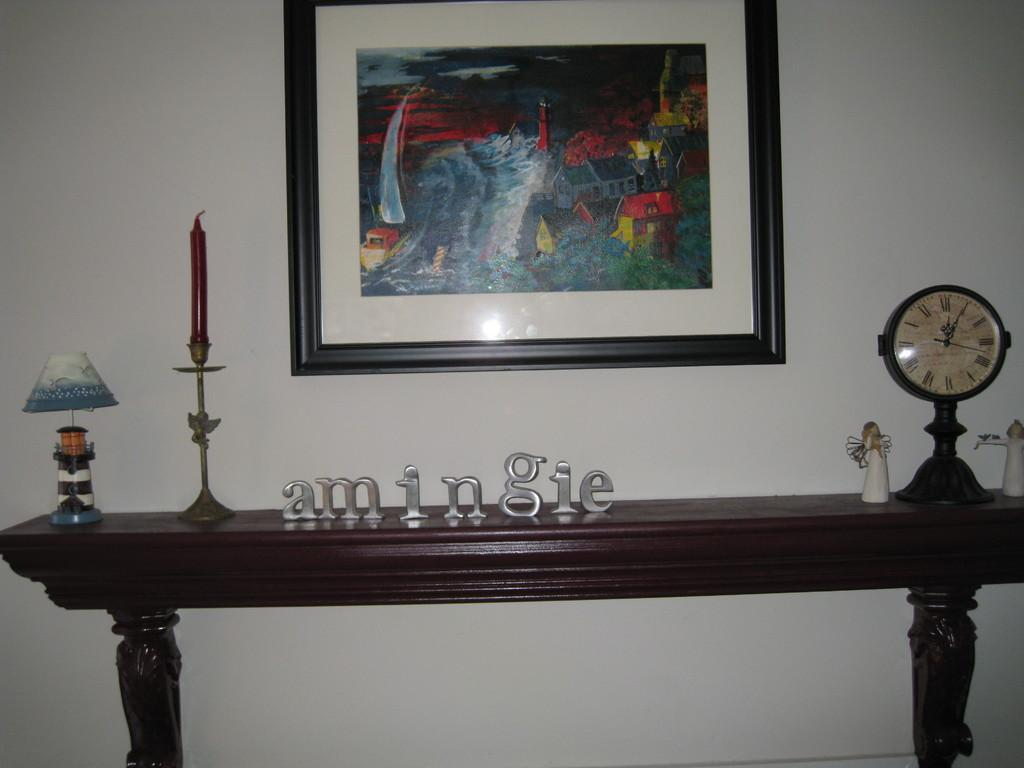<image>
Summarize the visual content of the image. The word amingie is displayed in metal lettering on a side table. 